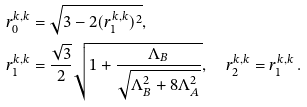Convert formula to latex. <formula><loc_0><loc_0><loc_500><loc_500>r _ { 0 } ^ { k , k } & = \sqrt { 3 - 2 ( r _ { 1 } ^ { k , k } ) ^ { 2 } } , \\ r _ { 1 } ^ { k , k } & = \frac { \sqrt { 3 } } { 2 } \sqrt { 1 + \frac { \Lambda _ { B } } { \sqrt { \Lambda _ { B } ^ { 2 } + 8 \Lambda _ { A } ^ { 2 } } } } , \quad r _ { 2 } ^ { k , k } = r _ { 1 } ^ { k , k } \, .</formula> 